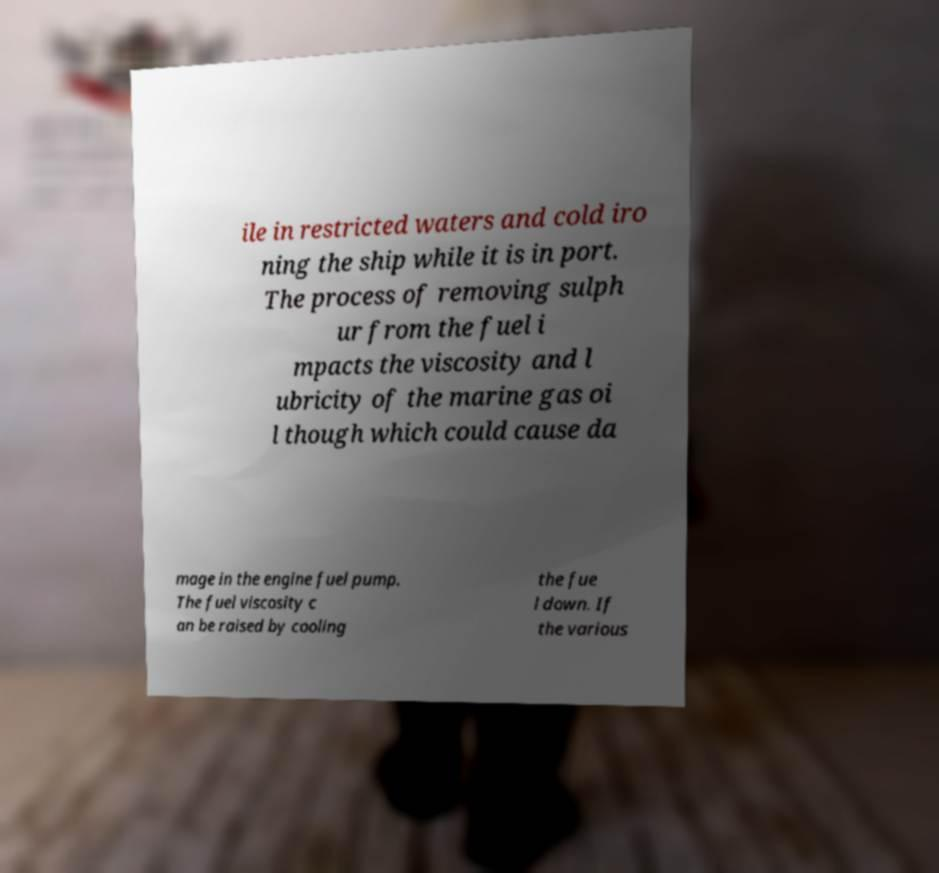Could you assist in decoding the text presented in this image and type it out clearly? ile in restricted waters and cold iro ning the ship while it is in port. The process of removing sulph ur from the fuel i mpacts the viscosity and l ubricity of the marine gas oi l though which could cause da mage in the engine fuel pump. The fuel viscosity c an be raised by cooling the fue l down. If the various 